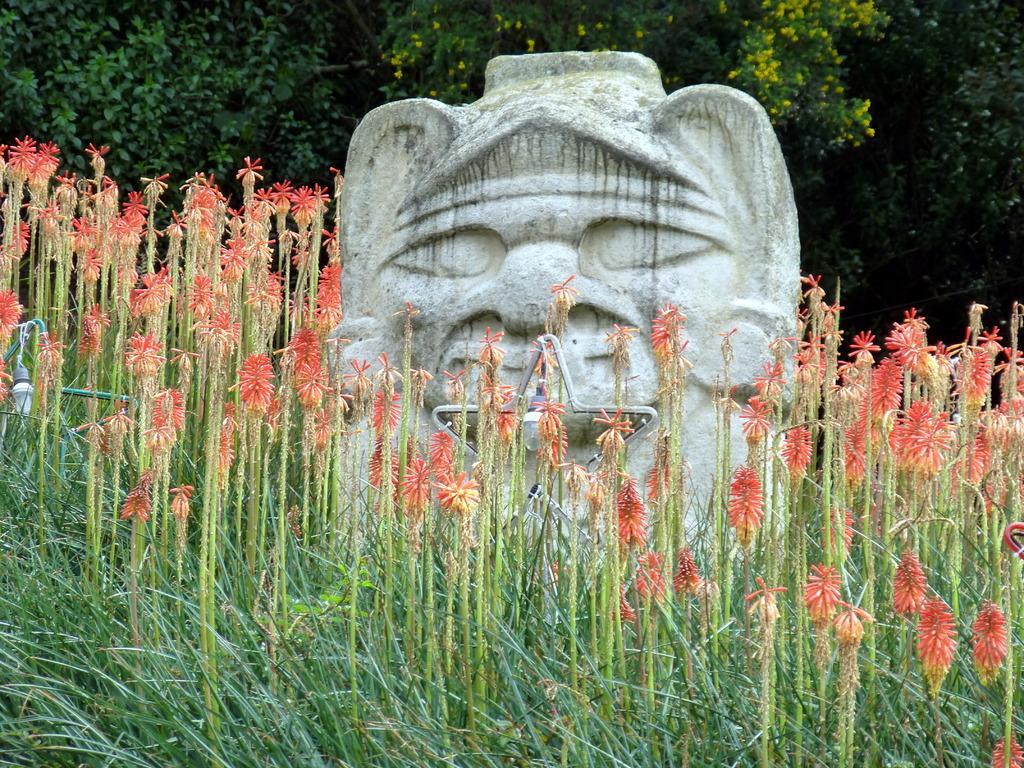How would you summarize this image in a sentence or two? In this image there are plants light, sculpture, in the background there are trees with flowers. 